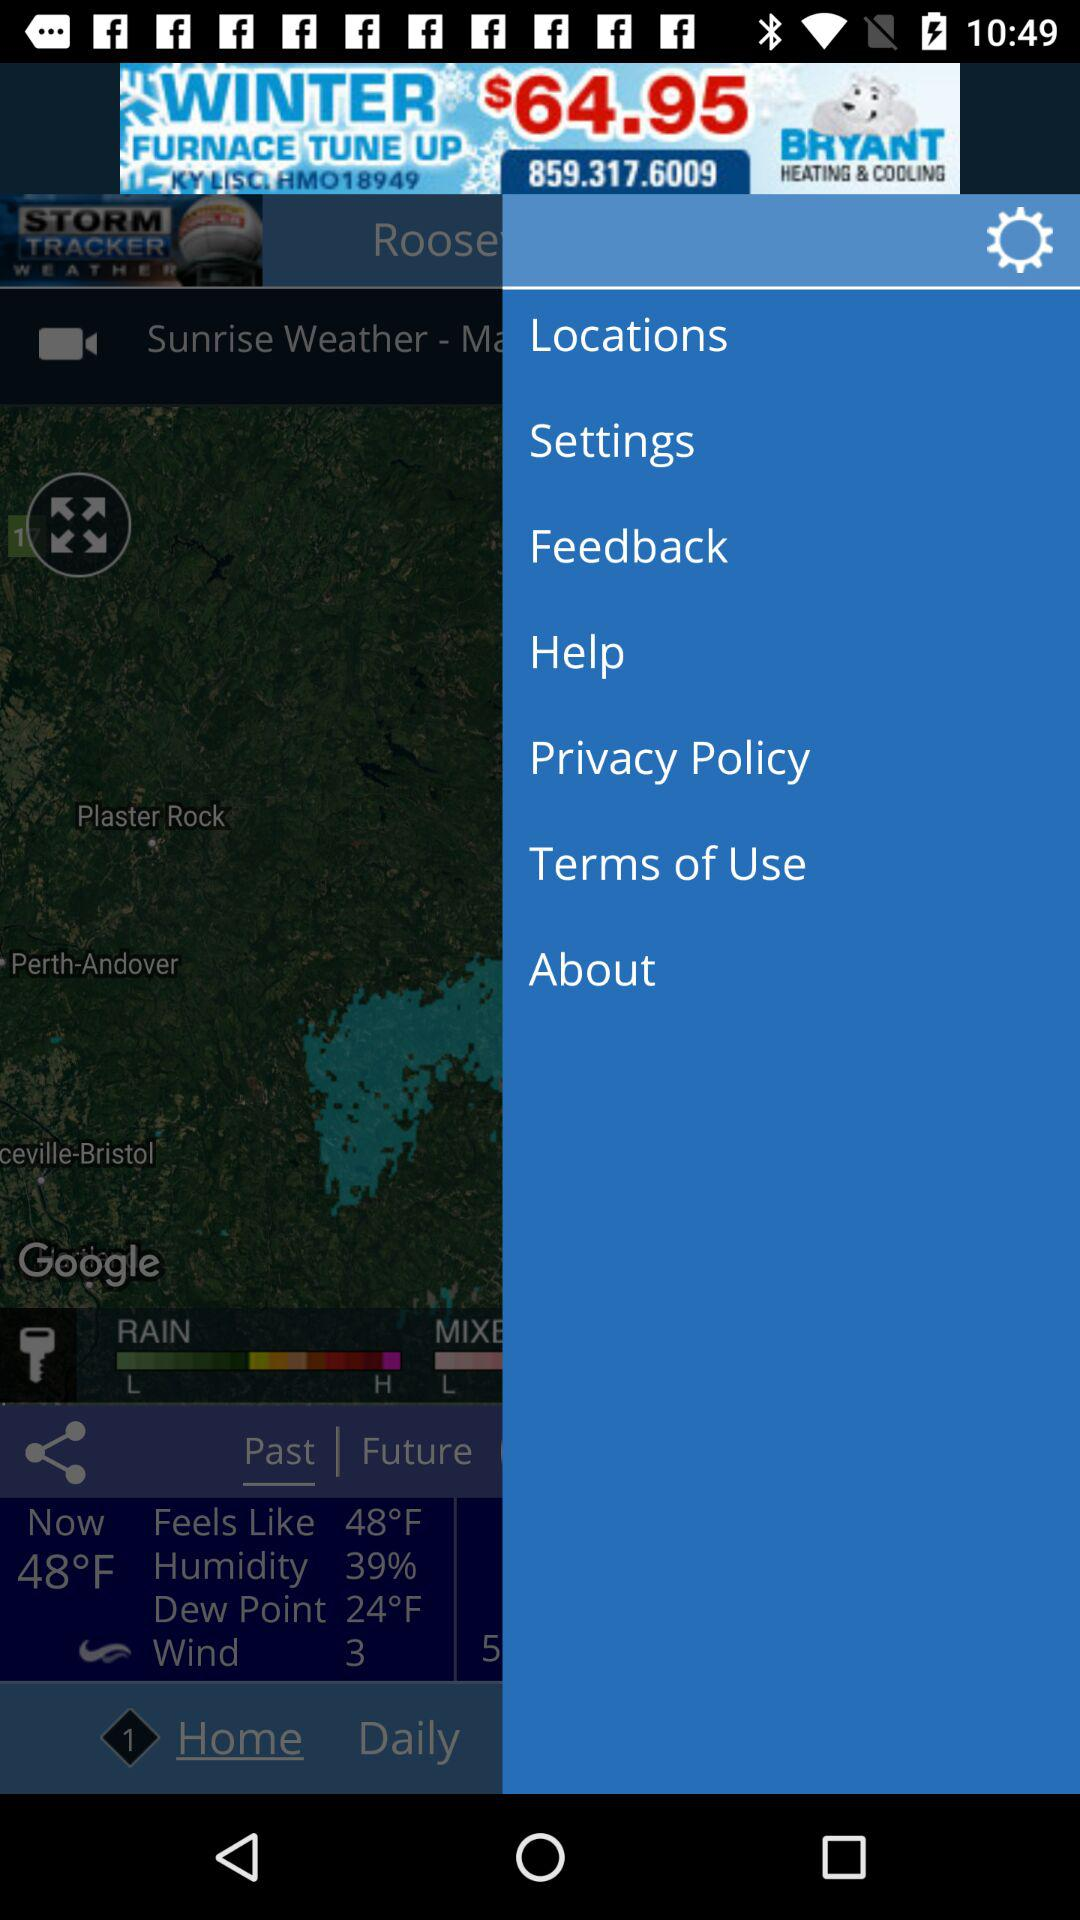How many degrees Fahrenheit is the difference between the current temperature and the dew point? Based on the provided weather information, the current temperature is 48°F and the dew point is 24°F. To calculate the difference between these two measurements, simply subtract the dew point from the current temperature, which results in a difference of 24°F. This difference is important as it indicates the level of comfort and the potential for precipitation. The larger the gap, the drier the air is, and typically, the more comfortable the conditions are for most people. 